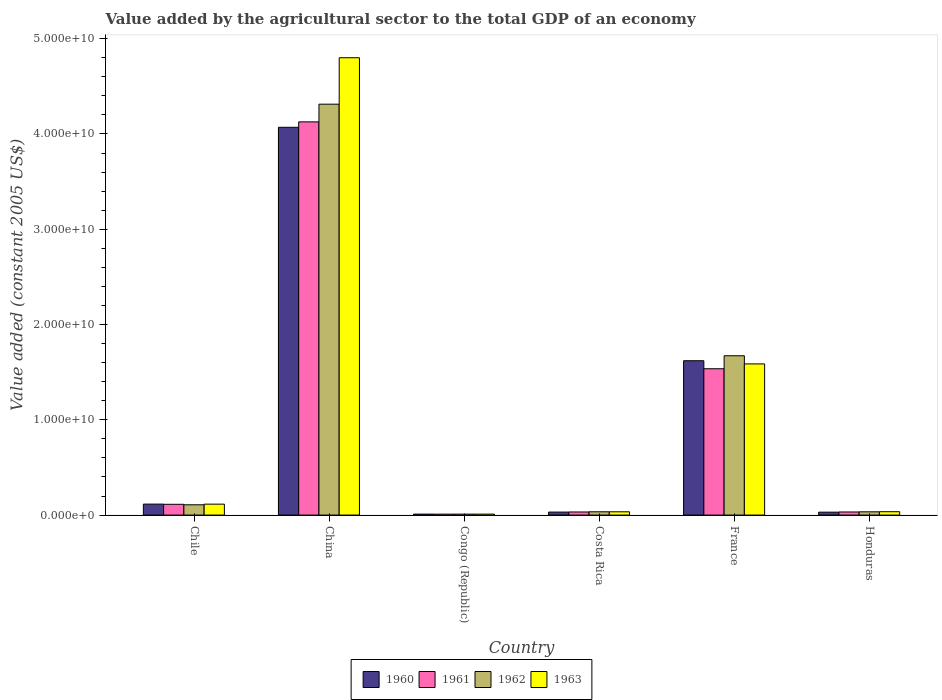How many different coloured bars are there?
Your answer should be compact. 4. How many groups of bars are there?
Offer a very short reply. 6. What is the label of the 4th group of bars from the left?
Offer a terse response. Costa Rica. What is the value added by the agricultural sector in 1961 in Congo (Republic)?
Make the answer very short. 9.74e+07. Across all countries, what is the maximum value added by the agricultural sector in 1961?
Ensure brevity in your answer.  4.13e+1. Across all countries, what is the minimum value added by the agricultural sector in 1962?
Provide a short and direct response. 9.79e+07. In which country was the value added by the agricultural sector in 1963 maximum?
Ensure brevity in your answer.  China. In which country was the value added by the agricultural sector in 1961 minimum?
Offer a terse response. Congo (Republic). What is the total value added by the agricultural sector in 1961 in the graph?
Provide a succinct answer. 5.85e+1. What is the difference between the value added by the agricultural sector in 1963 in Chile and that in Honduras?
Keep it short and to the point. 7.93e+08. What is the difference between the value added by the agricultural sector in 1961 in Honduras and the value added by the agricultural sector in 1962 in China?
Offer a very short reply. -4.28e+1. What is the average value added by the agricultural sector in 1960 per country?
Your answer should be very brief. 9.79e+09. What is the difference between the value added by the agricultural sector of/in 1963 and value added by the agricultural sector of/in 1960 in China?
Your answer should be compact. 7.30e+09. What is the ratio of the value added by the agricultural sector in 1963 in Congo (Republic) to that in France?
Make the answer very short. 0.01. What is the difference between the highest and the second highest value added by the agricultural sector in 1963?
Make the answer very short. -4.69e+1. What is the difference between the highest and the lowest value added by the agricultural sector in 1962?
Offer a terse response. 4.30e+1. What does the 2nd bar from the left in Congo (Republic) represents?
Your answer should be compact. 1961. Is it the case that in every country, the sum of the value added by the agricultural sector in 1961 and value added by the agricultural sector in 1960 is greater than the value added by the agricultural sector in 1962?
Your answer should be compact. Yes. How many bars are there?
Your answer should be very brief. 24. Are all the bars in the graph horizontal?
Give a very brief answer. No. What is the difference between two consecutive major ticks on the Y-axis?
Offer a very short reply. 1.00e+1. Are the values on the major ticks of Y-axis written in scientific E-notation?
Your response must be concise. Yes. Does the graph contain any zero values?
Keep it short and to the point. No. Does the graph contain grids?
Your answer should be very brief. No. What is the title of the graph?
Offer a very short reply. Value added by the agricultural sector to the total GDP of an economy. Does "1985" appear as one of the legend labels in the graph?
Provide a succinct answer. No. What is the label or title of the X-axis?
Offer a terse response. Country. What is the label or title of the Y-axis?
Your answer should be compact. Value added (constant 2005 US$). What is the Value added (constant 2005 US$) of 1960 in Chile?
Ensure brevity in your answer.  1.15e+09. What is the Value added (constant 2005 US$) of 1961 in Chile?
Your response must be concise. 1.13e+09. What is the Value added (constant 2005 US$) of 1962 in Chile?
Your answer should be compact. 1.08e+09. What is the Value added (constant 2005 US$) in 1963 in Chile?
Give a very brief answer. 1.15e+09. What is the Value added (constant 2005 US$) of 1960 in China?
Offer a very short reply. 4.07e+1. What is the Value added (constant 2005 US$) of 1961 in China?
Make the answer very short. 4.13e+1. What is the Value added (constant 2005 US$) in 1962 in China?
Your answer should be compact. 4.31e+1. What is the Value added (constant 2005 US$) in 1963 in China?
Keep it short and to the point. 4.80e+1. What is the Value added (constant 2005 US$) in 1960 in Congo (Republic)?
Ensure brevity in your answer.  1.01e+08. What is the Value added (constant 2005 US$) of 1961 in Congo (Republic)?
Provide a succinct answer. 9.74e+07. What is the Value added (constant 2005 US$) of 1962 in Congo (Republic)?
Provide a short and direct response. 9.79e+07. What is the Value added (constant 2005 US$) of 1963 in Congo (Republic)?
Keep it short and to the point. 9.86e+07. What is the Value added (constant 2005 US$) of 1960 in Costa Rica?
Your response must be concise. 3.13e+08. What is the Value added (constant 2005 US$) in 1961 in Costa Rica?
Your response must be concise. 3.24e+08. What is the Value added (constant 2005 US$) of 1962 in Costa Rica?
Offer a very short reply. 3.44e+08. What is the Value added (constant 2005 US$) of 1963 in Costa Rica?
Your answer should be compact. 3.43e+08. What is the Value added (constant 2005 US$) of 1960 in France?
Your answer should be very brief. 1.62e+1. What is the Value added (constant 2005 US$) in 1961 in France?
Your answer should be very brief. 1.54e+1. What is the Value added (constant 2005 US$) of 1962 in France?
Offer a terse response. 1.67e+1. What is the Value added (constant 2005 US$) of 1963 in France?
Your answer should be very brief. 1.59e+1. What is the Value added (constant 2005 US$) in 1960 in Honduras?
Provide a short and direct response. 3.05e+08. What is the Value added (constant 2005 US$) of 1961 in Honduras?
Make the answer very short. 3.25e+08. What is the Value added (constant 2005 US$) of 1962 in Honduras?
Offer a terse response. 3.41e+08. What is the Value added (constant 2005 US$) in 1963 in Honduras?
Provide a short and direct response. 3.53e+08. Across all countries, what is the maximum Value added (constant 2005 US$) in 1960?
Offer a very short reply. 4.07e+1. Across all countries, what is the maximum Value added (constant 2005 US$) of 1961?
Provide a short and direct response. 4.13e+1. Across all countries, what is the maximum Value added (constant 2005 US$) of 1962?
Your answer should be very brief. 4.31e+1. Across all countries, what is the maximum Value added (constant 2005 US$) of 1963?
Your answer should be compact. 4.80e+1. Across all countries, what is the minimum Value added (constant 2005 US$) in 1960?
Your response must be concise. 1.01e+08. Across all countries, what is the minimum Value added (constant 2005 US$) of 1961?
Your response must be concise. 9.74e+07. Across all countries, what is the minimum Value added (constant 2005 US$) of 1962?
Offer a terse response. 9.79e+07. Across all countries, what is the minimum Value added (constant 2005 US$) in 1963?
Offer a terse response. 9.86e+07. What is the total Value added (constant 2005 US$) of 1960 in the graph?
Your response must be concise. 5.88e+1. What is the total Value added (constant 2005 US$) of 1961 in the graph?
Keep it short and to the point. 5.85e+1. What is the total Value added (constant 2005 US$) in 1962 in the graph?
Keep it short and to the point. 6.17e+1. What is the total Value added (constant 2005 US$) in 1963 in the graph?
Your response must be concise. 6.58e+1. What is the difference between the Value added (constant 2005 US$) of 1960 in Chile and that in China?
Make the answer very short. -3.95e+1. What is the difference between the Value added (constant 2005 US$) of 1961 in Chile and that in China?
Provide a short and direct response. -4.01e+1. What is the difference between the Value added (constant 2005 US$) of 1962 in Chile and that in China?
Offer a very short reply. -4.20e+1. What is the difference between the Value added (constant 2005 US$) in 1963 in Chile and that in China?
Make the answer very short. -4.69e+1. What is the difference between the Value added (constant 2005 US$) of 1960 in Chile and that in Congo (Republic)?
Offer a very short reply. 1.05e+09. What is the difference between the Value added (constant 2005 US$) of 1961 in Chile and that in Congo (Republic)?
Give a very brief answer. 1.03e+09. What is the difference between the Value added (constant 2005 US$) in 1962 in Chile and that in Congo (Republic)?
Keep it short and to the point. 9.81e+08. What is the difference between the Value added (constant 2005 US$) in 1963 in Chile and that in Congo (Republic)?
Give a very brief answer. 1.05e+09. What is the difference between the Value added (constant 2005 US$) in 1960 in Chile and that in Costa Rica?
Offer a terse response. 8.39e+08. What is the difference between the Value added (constant 2005 US$) in 1961 in Chile and that in Costa Rica?
Give a very brief answer. 8.06e+08. What is the difference between the Value added (constant 2005 US$) of 1962 in Chile and that in Costa Rica?
Offer a very short reply. 7.35e+08. What is the difference between the Value added (constant 2005 US$) of 1963 in Chile and that in Costa Rica?
Give a very brief answer. 8.03e+08. What is the difference between the Value added (constant 2005 US$) in 1960 in Chile and that in France?
Make the answer very short. -1.50e+1. What is the difference between the Value added (constant 2005 US$) of 1961 in Chile and that in France?
Give a very brief answer. -1.42e+1. What is the difference between the Value added (constant 2005 US$) in 1962 in Chile and that in France?
Give a very brief answer. -1.56e+1. What is the difference between the Value added (constant 2005 US$) in 1963 in Chile and that in France?
Keep it short and to the point. -1.47e+1. What is the difference between the Value added (constant 2005 US$) of 1960 in Chile and that in Honduras?
Your answer should be very brief. 8.46e+08. What is the difference between the Value added (constant 2005 US$) of 1961 in Chile and that in Honduras?
Keep it short and to the point. 8.05e+08. What is the difference between the Value added (constant 2005 US$) of 1962 in Chile and that in Honduras?
Offer a very short reply. 7.38e+08. What is the difference between the Value added (constant 2005 US$) in 1963 in Chile and that in Honduras?
Offer a terse response. 7.93e+08. What is the difference between the Value added (constant 2005 US$) in 1960 in China and that in Congo (Republic)?
Ensure brevity in your answer.  4.06e+1. What is the difference between the Value added (constant 2005 US$) in 1961 in China and that in Congo (Republic)?
Your answer should be compact. 4.12e+1. What is the difference between the Value added (constant 2005 US$) of 1962 in China and that in Congo (Republic)?
Your answer should be compact. 4.30e+1. What is the difference between the Value added (constant 2005 US$) in 1963 in China and that in Congo (Republic)?
Provide a succinct answer. 4.79e+1. What is the difference between the Value added (constant 2005 US$) in 1960 in China and that in Costa Rica?
Your answer should be compact. 4.04e+1. What is the difference between the Value added (constant 2005 US$) of 1961 in China and that in Costa Rica?
Offer a very short reply. 4.09e+1. What is the difference between the Value added (constant 2005 US$) of 1962 in China and that in Costa Rica?
Provide a succinct answer. 4.28e+1. What is the difference between the Value added (constant 2005 US$) in 1963 in China and that in Costa Rica?
Your answer should be compact. 4.77e+1. What is the difference between the Value added (constant 2005 US$) of 1960 in China and that in France?
Your answer should be very brief. 2.45e+1. What is the difference between the Value added (constant 2005 US$) of 1961 in China and that in France?
Offer a very short reply. 2.59e+1. What is the difference between the Value added (constant 2005 US$) of 1962 in China and that in France?
Make the answer very short. 2.64e+1. What is the difference between the Value added (constant 2005 US$) of 1963 in China and that in France?
Offer a very short reply. 3.21e+1. What is the difference between the Value added (constant 2005 US$) of 1960 in China and that in Honduras?
Give a very brief answer. 4.04e+1. What is the difference between the Value added (constant 2005 US$) in 1961 in China and that in Honduras?
Your answer should be very brief. 4.09e+1. What is the difference between the Value added (constant 2005 US$) of 1962 in China and that in Honduras?
Provide a short and direct response. 4.28e+1. What is the difference between the Value added (constant 2005 US$) in 1963 in China and that in Honduras?
Provide a succinct answer. 4.76e+1. What is the difference between the Value added (constant 2005 US$) in 1960 in Congo (Republic) and that in Costa Rica?
Make the answer very short. -2.12e+08. What is the difference between the Value added (constant 2005 US$) in 1961 in Congo (Republic) and that in Costa Rica?
Your response must be concise. -2.27e+08. What is the difference between the Value added (constant 2005 US$) in 1962 in Congo (Republic) and that in Costa Rica?
Your answer should be compact. -2.46e+08. What is the difference between the Value added (constant 2005 US$) of 1963 in Congo (Republic) and that in Costa Rica?
Your answer should be very brief. -2.45e+08. What is the difference between the Value added (constant 2005 US$) in 1960 in Congo (Republic) and that in France?
Your answer should be compact. -1.61e+1. What is the difference between the Value added (constant 2005 US$) in 1961 in Congo (Republic) and that in France?
Give a very brief answer. -1.53e+1. What is the difference between the Value added (constant 2005 US$) of 1962 in Congo (Republic) and that in France?
Offer a very short reply. -1.66e+1. What is the difference between the Value added (constant 2005 US$) in 1963 in Congo (Republic) and that in France?
Keep it short and to the point. -1.58e+1. What is the difference between the Value added (constant 2005 US$) of 1960 in Congo (Republic) and that in Honduras?
Make the answer very short. -2.04e+08. What is the difference between the Value added (constant 2005 US$) in 1961 in Congo (Republic) and that in Honduras?
Provide a succinct answer. -2.28e+08. What is the difference between the Value added (constant 2005 US$) in 1962 in Congo (Republic) and that in Honduras?
Ensure brevity in your answer.  -2.43e+08. What is the difference between the Value added (constant 2005 US$) of 1963 in Congo (Republic) and that in Honduras?
Keep it short and to the point. -2.55e+08. What is the difference between the Value added (constant 2005 US$) in 1960 in Costa Rica and that in France?
Offer a terse response. -1.59e+1. What is the difference between the Value added (constant 2005 US$) of 1961 in Costa Rica and that in France?
Your response must be concise. -1.50e+1. What is the difference between the Value added (constant 2005 US$) of 1962 in Costa Rica and that in France?
Make the answer very short. -1.64e+1. What is the difference between the Value added (constant 2005 US$) in 1963 in Costa Rica and that in France?
Provide a succinct answer. -1.55e+1. What is the difference between the Value added (constant 2005 US$) of 1960 in Costa Rica and that in Honduras?
Give a very brief answer. 7.61e+06. What is the difference between the Value added (constant 2005 US$) of 1961 in Costa Rica and that in Honduras?
Your answer should be compact. -8.14e+05. What is the difference between the Value added (constant 2005 US$) of 1962 in Costa Rica and that in Honduras?
Offer a very short reply. 3.61e+06. What is the difference between the Value added (constant 2005 US$) in 1963 in Costa Rica and that in Honduras?
Provide a short and direct response. -9.78e+06. What is the difference between the Value added (constant 2005 US$) of 1960 in France and that in Honduras?
Make the answer very short. 1.59e+1. What is the difference between the Value added (constant 2005 US$) of 1961 in France and that in Honduras?
Give a very brief answer. 1.50e+1. What is the difference between the Value added (constant 2005 US$) of 1962 in France and that in Honduras?
Provide a short and direct response. 1.64e+1. What is the difference between the Value added (constant 2005 US$) in 1963 in France and that in Honduras?
Your answer should be compact. 1.55e+1. What is the difference between the Value added (constant 2005 US$) of 1960 in Chile and the Value added (constant 2005 US$) of 1961 in China?
Ensure brevity in your answer.  -4.01e+1. What is the difference between the Value added (constant 2005 US$) in 1960 in Chile and the Value added (constant 2005 US$) in 1962 in China?
Offer a terse response. -4.20e+1. What is the difference between the Value added (constant 2005 US$) of 1960 in Chile and the Value added (constant 2005 US$) of 1963 in China?
Offer a very short reply. -4.68e+1. What is the difference between the Value added (constant 2005 US$) in 1961 in Chile and the Value added (constant 2005 US$) in 1962 in China?
Keep it short and to the point. -4.20e+1. What is the difference between the Value added (constant 2005 US$) of 1961 in Chile and the Value added (constant 2005 US$) of 1963 in China?
Your answer should be very brief. -4.69e+1. What is the difference between the Value added (constant 2005 US$) in 1962 in Chile and the Value added (constant 2005 US$) in 1963 in China?
Ensure brevity in your answer.  -4.69e+1. What is the difference between the Value added (constant 2005 US$) of 1960 in Chile and the Value added (constant 2005 US$) of 1961 in Congo (Republic)?
Offer a very short reply. 1.05e+09. What is the difference between the Value added (constant 2005 US$) of 1960 in Chile and the Value added (constant 2005 US$) of 1962 in Congo (Republic)?
Your response must be concise. 1.05e+09. What is the difference between the Value added (constant 2005 US$) in 1960 in Chile and the Value added (constant 2005 US$) in 1963 in Congo (Republic)?
Your answer should be compact. 1.05e+09. What is the difference between the Value added (constant 2005 US$) of 1961 in Chile and the Value added (constant 2005 US$) of 1962 in Congo (Republic)?
Provide a succinct answer. 1.03e+09. What is the difference between the Value added (constant 2005 US$) of 1961 in Chile and the Value added (constant 2005 US$) of 1963 in Congo (Republic)?
Your answer should be compact. 1.03e+09. What is the difference between the Value added (constant 2005 US$) of 1962 in Chile and the Value added (constant 2005 US$) of 1963 in Congo (Republic)?
Offer a very short reply. 9.81e+08. What is the difference between the Value added (constant 2005 US$) in 1960 in Chile and the Value added (constant 2005 US$) in 1961 in Costa Rica?
Make the answer very short. 8.27e+08. What is the difference between the Value added (constant 2005 US$) of 1960 in Chile and the Value added (constant 2005 US$) of 1962 in Costa Rica?
Give a very brief answer. 8.07e+08. What is the difference between the Value added (constant 2005 US$) in 1960 in Chile and the Value added (constant 2005 US$) in 1963 in Costa Rica?
Your response must be concise. 8.08e+08. What is the difference between the Value added (constant 2005 US$) in 1961 in Chile and the Value added (constant 2005 US$) in 1962 in Costa Rica?
Keep it short and to the point. 7.86e+08. What is the difference between the Value added (constant 2005 US$) in 1961 in Chile and the Value added (constant 2005 US$) in 1963 in Costa Rica?
Keep it short and to the point. 7.87e+08. What is the difference between the Value added (constant 2005 US$) of 1962 in Chile and the Value added (constant 2005 US$) of 1963 in Costa Rica?
Ensure brevity in your answer.  7.36e+08. What is the difference between the Value added (constant 2005 US$) in 1960 in Chile and the Value added (constant 2005 US$) in 1961 in France?
Offer a very short reply. -1.42e+1. What is the difference between the Value added (constant 2005 US$) of 1960 in Chile and the Value added (constant 2005 US$) of 1962 in France?
Offer a very short reply. -1.56e+1. What is the difference between the Value added (constant 2005 US$) in 1960 in Chile and the Value added (constant 2005 US$) in 1963 in France?
Make the answer very short. -1.47e+1. What is the difference between the Value added (constant 2005 US$) of 1961 in Chile and the Value added (constant 2005 US$) of 1962 in France?
Make the answer very short. -1.56e+1. What is the difference between the Value added (constant 2005 US$) in 1961 in Chile and the Value added (constant 2005 US$) in 1963 in France?
Ensure brevity in your answer.  -1.47e+1. What is the difference between the Value added (constant 2005 US$) of 1962 in Chile and the Value added (constant 2005 US$) of 1963 in France?
Make the answer very short. -1.48e+1. What is the difference between the Value added (constant 2005 US$) in 1960 in Chile and the Value added (constant 2005 US$) in 1961 in Honduras?
Offer a very short reply. 8.27e+08. What is the difference between the Value added (constant 2005 US$) in 1960 in Chile and the Value added (constant 2005 US$) in 1962 in Honduras?
Provide a succinct answer. 8.11e+08. What is the difference between the Value added (constant 2005 US$) in 1960 in Chile and the Value added (constant 2005 US$) in 1963 in Honduras?
Ensure brevity in your answer.  7.99e+08. What is the difference between the Value added (constant 2005 US$) in 1961 in Chile and the Value added (constant 2005 US$) in 1962 in Honduras?
Make the answer very short. 7.90e+08. What is the difference between the Value added (constant 2005 US$) in 1961 in Chile and the Value added (constant 2005 US$) in 1963 in Honduras?
Give a very brief answer. 7.78e+08. What is the difference between the Value added (constant 2005 US$) in 1962 in Chile and the Value added (constant 2005 US$) in 1963 in Honduras?
Ensure brevity in your answer.  7.26e+08. What is the difference between the Value added (constant 2005 US$) in 1960 in China and the Value added (constant 2005 US$) in 1961 in Congo (Republic)?
Your answer should be compact. 4.06e+1. What is the difference between the Value added (constant 2005 US$) in 1960 in China and the Value added (constant 2005 US$) in 1962 in Congo (Republic)?
Offer a very short reply. 4.06e+1. What is the difference between the Value added (constant 2005 US$) in 1960 in China and the Value added (constant 2005 US$) in 1963 in Congo (Republic)?
Make the answer very short. 4.06e+1. What is the difference between the Value added (constant 2005 US$) in 1961 in China and the Value added (constant 2005 US$) in 1962 in Congo (Republic)?
Give a very brief answer. 4.12e+1. What is the difference between the Value added (constant 2005 US$) of 1961 in China and the Value added (constant 2005 US$) of 1963 in Congo (Republic)?
Make the answer very short. 4.12e+1. What is the difference between the Value added (constant 2005 US$) in 1962 in China and the Value added (constant 2005 US$) in 1963 in Congo (Republic)?
Ensure brevity in your answer.  4.30e+1. What is the difference between the Value added (constant 2005 US$) of 1960 in China and the Value added (constant 2005 US$) of 1961 in Costa Rica?
Your answer should be very brief. 4.04e+1. What is the difference between the Value added (constant 2005 US$) of 1960 in China and the Value added (constant 2005 US$) of 1962 in Costa Rica?
Give a very brief answer. 4.04e+1. What is the difference between the Value added (constant 2005 US$) of 1960 in China and the Value added (constant 2005 US$) of 1963 in Costa Rica?
Offer a terse response. 4.04e+1. What is the difference between the Value added (constant 2005 US$) in 1961 in China and the Value added (constant 2005 US$) in 1962 in Costa Rica?
Offer a terse response. 4.09e+1. What is the difference between the Value added (constant 2005 US$) of 1961 in China and the Value added (constant 2005 US$) of 1963 in Costa Rica?
Provide a succinct answer. 4.09e+1. What is the difference between the Value added (constant 2005 US$) of 1962 in China and the Value added (constant 2005 US$) of 1963 in Costa Rica?
Give a very brief answer. 4.28e+1. What is the difference between the Value added (constant 2005 US$) in 1960 in China and the Value added (constant 2005 US$) in 1961 in France?
Give a very brief answer. 2.53e+1. What is the difference between the Value added (constant 2005 US$) of 1960 in China and the Value added (constant 2005 US$) of 1962 in France?
Ensure brevity in your answer.  2.40e+1. What is the difference between the Value added (constant 2005 US$) of 1960 in China and the Value added (constant 2005 US$) of 1963 in France?
Offer a terse response. 2.48e+1. What is the difference between the Value added (constant 2005 US$) of 1961 in China and the Value added (constant 2005 US$) of 1962 in France?
Offer a very short reply. 2.45e+1. What is the difference between the Value added (constant 2005 US$) of 1961 in China and the Value added (constant 2005 US$) of 1963 in France?
Make the answer very short. 2.54e+1. What is the difference between the Value added (constant 2005 US$) of 1962 in China and the Value added (constant 2005 US$) of 1963 in France?
Offer a terse response. 2.73e+1. What is the difference between the Value added (constant 2005 US$) of 1960 in China and the Value added (constant 2005 US$) of 1961 in Honduras?
Your answer should be compact. 4.04e+1. What is the difference between the Value added (constant 2005 US$) of 1960 in China and the Value added (constant 2005 US$) of 1962 in Honduras?
Your answer should be compact. 4.04e+1. What is the difference between the Value added (constant 2005 US$) of 1960 in China and the Value added (constant 2005 US$) of 1963 in Honduras?
Ensure brevity in your answer.  4.03e+1. What is the difference between the Value added (constant 2005 US$) in 1961 in China and the Value added (constant 2005 US$) in 1962 in Honduras?
Make the answer very short. 4.09e+1. What is the difference between the Value added (constant 2005 US$) in 1961 in China and the Value added (constant 2005 US$) in 1963 in Honduras?
Your answer should be compact. 4.09e+1. What is the difference between the Value added (constant 2005 US$) of 1962 in China and the Value added (constant 2005 US$) of 1963 in Honduras?
Keep it short and to the point. 4.28e+1. What is the difference between the Value added (constant 2005 US$) in 1960 in Congo (Republic) and the Value added (constant 2005 US$) in 1961 in Costa Rica?
Ensure brevity in your answer.  -2.24e+08. What is the difference between the Value added (constant 2005 US$) of 1960 in Congo (Republic) and the Value added (constant 2005 US$) of 1962 in Costa Rica?
Keep it short and to the point. -2.43e+08. What is the difference between the Value added (constant 2005 US$) of 1960 in Congo (Republic) and the Value added (constant 2005 US$) of 1963 in Costa Rica?
Offer a very short reply. -2.42e+08. What is the difference between the Value added (constant 2005 US$) of 1961 in Congo (Republic) and the Value added (constant 2005 US$) of 1962 in Costa Rica?
Provide a short and direct response. -2.47e+08. What is the difference between the Value added (constant 2005 US$) in 1961 in Congo (Republic) and the Value added (constant 2005 US$) in 1963 in Costa Rica?
Make the answer very short. -2.46e+08. What is the difference between the Value added (constant 2005 US$) in 1962 in Congo (Republic) and the Value added (constant 2005 US$) in 1963 in Costa Rica?
Your response must be concise. -2.45e+08. What is the difference between the Value added (constant 2005 US$) of 1960 in Congo (Republic) and the Value added (constant 2005 US$) of 1961 in France?
Offer a very short reply. -1.53e+1. What is the difference between the Value added (constant 2005 US$) of 1960 in Congo (Republic) and the Value added (constant 2005 US$) of 1962 in France?
Make the answer very short. -1.66e+1. What is the difference between the Value added (constant 2005 US$) of 1960 in Congo (Republic) and the Value added (constant 2005 US$) of 1963 in France?
Offer a terse response. -1.58e+1. What is the difference between the Value added (constant 2005 US$) in 1961 in Congo (Republic) and the Value added (constant 2005 US$) in 1962 in France?
Provide a succinct answer. -1.66e+1. What is the difference between the Value added (constant 2005 US$) in 1961 in Congo (Republic) and the Value added (constant 2005 US$) in 1963 in France?
Provide a short and direct response. -1.58e+1. What is the difference between the Value added (constant 2005 US$) of 1962 in Congo (Republic) and the Value added (constant 2005 US$) of 1963 in France?
Offer a very short reply. -1.58e+1. What is the difference between the Value added (constant 2005 US$) in 1960 in Congo (Republic) and the Value added (constant 2005 US$) in 1961 in Honduras?
Make the answer very short. -2.24e+08. What is the difference between the Value added (constant 2005 US$) in 1960 in Congo (Republic) and the Value added (constant 2005 US$) in 1962 in Honduras?
Offer a very short reply. -2.40e+08. What is the difference between the Value added (constant 2005 US$) in 1960 in Congo (Republic) and the Value added (constant 2005 US$) in 1963 in Honduras?
Give a very brief answer. -2.52e+08. What is the difference between the Value added (constant 2005 US$) in 1961 in Congo (Republic) and the Value added (constant 2005 US$) in 1962 in Honduras?
Give a very brief answer. -2.43e+08. What is the difference between the Value added (constant 2005 US$) in 1961 in Congo (Republic) and the Value added (constant 2005 US$) in 1963 in Honduras?
Your answer should be compact. -2.56e+08. What is the difference between the Value added (constant 2005 US$) of 1962 in Congo (Republic) and the Value added (constant 2005 US$) of 1963 in Honduras?
Provide a succinct answer. -2.55e+08. What is the difference between the Value added (constant 2005 US$) of 1960 in Costa Rica and the Value added (constant 2005 US$) of 1961 in France?
Make the answer very short. -1.50e+1. What is the difference between the Value added (constant 2005 US$) in 1960 in Costa Rica and the Value added (constant 2005 US$) in 1962 in France?
Offer a very short reply. -1.64e+1. What is the difference between the Value added (constant 2005 US$) of 1960 in Costa Rica and the Value added (constant 2005 US$) of 1963 in France?
Provide a succinct answer. -1.56e+1. What is the difference between the Value added (constant 2005 US$) of 1961 in Costa Rica and the Value added (constant 2005 US$) of 1962 in France?
Make the answer very short. -1.64e+1. What is the difference between the Value added (constant 2005 US$) of 1961 in Costa Rica and the Value added (constant 2005 US$) of 1963 in France?
Your answer should be compact. -1.55e+1. What is the difference between the Value added (constant 2005 US$) of 1962 in Costa Rica and the Value added (constant 2005 US$) of 1963 in France?
Your response must be concise. -1.55e+1. What is the difference between the Value added (constant 2005 US$) of 1960 in Costa Rica and the Value added (constant 2005 US$) of 1961 in Honduras?
Provide a short and direct response. -1.23e+07. What is the difference between the Value added (constant 2005 US$) in 1960 in Costa Rica and the Value added (constant 2005 US$) in 1962 in Honduras?
Give a very brief answer. -2.78e+07. What is the difference between the Value added (constant 2005 US$) of 1960 in Costa Rica and the Value added (constant 2005 US$) of 1963 in Honduras?
Offer a very short reply. -4.02e+07. What is the difference between the Value added (constant 2005 US$) of 1961 in Costa Rica and the Value added (constant 2005 US$) of 1962 in Honduras?
Give a very brief answer. -1.63e+07. What is the difference between the Value added (constant 2005 US$) in 1961 in Costa Rica and the Value added (constant 2005 US$) in 1963 in Honduras?
Make the answer very short. -2.87e+07. What is the difference between the Value added (constant 2005 US$) of 1962 in Costa Rica and the Value added (constant 2005 US$) of 1963 in Honduras?
Offer a terse response. -8.78e+06. What is the difference between the Value added (constant 2005 US$) of 1960 in France and the Value added (constant 2005 US$) of 1961 in Honduras?
Offer a terse response. 1.59e+1. What is the difference between the Value added (constant 2005 US$) in 1960 in France and the Value added (constant 2005 US$) in 1962 in Honduras?
Offer a very short reply. 1.59e+1. What is the difference between the Value added (constant 2005 US$) of 1960 in France and the Value added (constant 2005 US$) of 1963 in Honduras?
Provide a short and direct response. 1.58e+1. What is the difference between the Value added (constant 2005 US$) in 1961 in France and the Value added (constant 2005 US$) in 1962 in Honduras?
Keep it short and to the point. 1.50e+1. What is the difference between the Value added (constant 2005 US$) of 1961 in France and the Value added (constant 2005 US$) of 1963 in Honduras?
Your answer should be compact. 1.50e+1. What is the difference between the Value added (constant 2005 US$) of 1962 in France and the Value added (constant 2005 US$) of 1963 in Honduras?
Provide a short and direct response. 1.64e+1. What is the average Value added (constant 2005 US$) in 1960 per country?
Provide a succinct answer. 9.79e+09. What is the average Value added (constant 2005 US$) of 1961 per country?
Provide a succinct answer. 9.75e+09. What is the average Value added (constant 2005 US$) of 1962 per country?
Your answer should be very brief. 1.03e+1. What is the average Value added (constant 2005 US$) of 1963 per country?
Offer a terse response. 1.10e+1. What is the difference between the Value added (constant 2005 US$) in 1960 and Value added (constant 2005 US$) in 1961 in Chile?
Provide a short and direct response. 2.12e+07. What is the difference between the Value added (constant 2005 US$) of 1960 and Value added (constant 2005 US$) of 1962 in Chile?
Your response must be concise. 7.27e+07. What is the difference between the Value added (constant 2005 US$) of 1960 and Value added (constant 2005 US$) of 1963 in Chile?
Ensure brevity in your answer.  5.74e+06. What is the difference between the Value added (constant 2005 US$) of 1961 and Value added (constant 2005 US$) of 1962 in Chile?
Keep it short and to the point. 5.15e+07. What is the difference between the Value added (constant 2005 US$) in 1961 and Value added (constant 2005 US$) in 1963 in Chile?
Provide a short and direct response. -1.54e+07. What is the difference between the Value added (constant 2005 US$) in 1962 and Value added (constant 2005 US$) in 1963 in Chile?
Provide a short and direct response. -6.69e+07. What is the difference between the Value added (constant 2005 US$) of 1960 and Value added (constant 2005 US$) of 1961 in China?
Give a very brief answer. -5.70e+08. What is the difference between the Value added (constant 2005 US$) in 1960 and Value added (constant 2005 US$) in 1962 in China?
Ensure brevity in your answer.  -2.43e+09. What is the difference between the Value added (constant 2005 US$) in 1960 and Value added (constant 2005 US$) in 1963 in China?
Ensure brevity in your answer.  -7.30e+09. What is the difference between the Value added (constant 2005 US$) in 1961 and Value added (constant 2005 US$) in 1962 in China?
Provide a short and direct response. -1.86e+09. What is the difference between the Value added (constant 2005 US$) of 1961 and Value added (constant 2005 US$) of 1963 in China?
Offer a terse response. -6.73e+09. What is the difference between the Value added (constant 2005 US$) in 1962 and Value added (constant 2005 US$) in 1963 in China?
Offer a very short reply. -4.87e+09. What is the difference between the Value added (constant 2005 US$) of 1960 and Value added (constant 2005 US$) of 1961 in Congo (Republic)?
Offer a terse response. 3.61e+06. What is the difference between the Value added (constant 2005 US$) in 1960 and Value added (constant 2005 US$) in 1962 in Congo (Republic)?
Make the answer very short. 3.02e+06. What is the difference between the Value added (constant 2005 US$) of 1960 and Value added (constant 2005 US$) of 1963 in Congo (Republic)?
Ensure brevity in your answer.  2.34e+06. What is the difference between the Value added (constant 2005 US$) in 1961 and Value added (constant 2005 US$) in 1962 in Congo (Republic)?
Your answer should be very brief. -5.86e+05. What is the difference between the Value added (constant 2005 US$) in 1961 and Value added (constant 2005 US$) in 1963 in Congo (Republic)?
Offer a terse response. -1.27e+06. What is the difference between the Value added (constant 2005 US$) in 1962 and Value added (constant 2005 US$) in 1963 in Congo (Republic)?
Provide a succinct answer. -6.85e+05. What is the difference between the Value added (constant 2005 US$) in 1960 and Value added (constant 2005 US$) in 1961 in Costa Rica?
Give a very brief answer. -1.15e+07. What is the difference between the Value added (constant 2005 US$) of 1960 and Value added (constant 2005 US$) of 1962 in Costa Rica?
Keep it short and to the point. -3.14e+07. What is the difference between the Value added (constant 2005 US$) of 1960 and Value added (constant 2005 US$) of 1963 in Costa Rica?
Ensure brevity in your answer.  -3.04e+07. What is the difference between the Value added (constant 2005 US$) of 1961 and Value added (constant 2005 US$) of 1962 in Costa Rica?
Your answer should be compact. -1.99e+07. What is the difference between the Value added (constant 2005 US$) in 1961 and Value added (constant 2005 US$) in 1963 in Costa Rica?
Provide a short and direct response. -1.89e+07. What is the difference between the Value added (constant 2005 US$) in 1962 and Value added (constant 2005 US$) in 1963 in Costa Rica?
Your answer should be very brief. 1.00e+06. What is the difference between the Value added (constant 2005 US$) in 1960 and Value added (constant 2005 US$) in 1961 in France?
Provide a short and direct response. 8.42e+08. What is the difference between the Value added (constant 2005 US$) of 1960 and Value added (constant 2005 US$) of 1962 in France?
Your answer should be very brief. -5.20e+08. What is the difference between the Value added (constant 2005 US$) in 1960 and Value added (constant 2005 US$) in 1963 in France?
Offer a very short reply. 3.35e+08. What is the difference between the Value added (constant 2005 US$) in 1961 and Value added (constant 2005 US$) in 1962 in France?
Keep it short and to the point. -1.36e+09. What is the difference between the Value added (constant 2005 US$) of 1961 and Value added (constant 2005 US$) of 1963 in France?
Your response must be concise. -5.07e+08. What is the difference between the Value added (constant 2005 US$) of 1962 and Value added (constant 2005 US$) of 1963 in France?
Give a very brief answer. 8.56e+08. What is the difference between the Value added (constant 2005 US$) of 1960 and Value added (constant 2005 US$) of 1961 in Honduras?
Give a very brief answer. -1.99e+07. What is the difference between the Value added (constant 2005 US$) in 1960 and Value added (constant 2005 US$) in 1962 in Honduras?
Provide a short and direct response. -3.54e+07. What is the difference between the Value added (constant 2005 US$) of 1960 and Value added (constant 2005 US$) of 1963 in Honduras?
Offer a very short reply. -4.78e+07. What is the difference between the Value added (constant 2005 US$) of 1961 and Value added (constant 2005 US$) of 1962 in Honduras?
Make the answer very short. -1.55e+07. What is the difference between the Value added (constant 2005 US$) in 1961 and Value added (constant 2005 US$) in 1963 in Honduras?
Offer a very short reply. -2.79e+07. What is the difference between the Value added (constant 2005 US$) of 1962 and Value added (constant 2005 US$) of 1963 in Honduras?
Ensure brevity in your answer.  -1.24e+07. What is the ratio of the Value added (constant 2005 US$) of 1960 in Chile to that in China?
Provide a succinct answer. 0.03. What is the ratio of the Value added (constant 2005 US$) of 1961 in Chile to that in China?
Offer a very short reply. 0.03. What is the ratio of the Value added (constant 2005 US$) of 1962 in Chile to that in China?
Keep it short and to the point. 0.03. What is the ratio of the Value added (constant 2005 US$) of 1963 in Chile to that in China?
Offer a very short reply. 0.02. What is the ratio of the Value added (constant 2005 US$) of 1960 in Chile to that in Congo (Republic)?
Offer a terse response. 11.41. What is the ratio of the Value added (constant 2005 US$) of 1961 in Chile to that in Congo (Republic)?
Offer a very short reply. 11.61. What is the ratio of the Value added (constant 2005 US$) of 1962 in Chile to that in Congo (Republic)?
Offer a terse response. 11.02. What is the ratio of the Value added (constant 2005 US$) in 1963 in Chile to that in Congo (Republic)?
Give a very brief answer. 11.62. What is the ratio of the Value added (constant 2005 US$) in 1960 in Chile to that in Costa Rica?
Offer a terse response. 3.68. What is the ratio of the Value added (constant 2005 US$) in 1961 in Chile to that in Costa Rica?
Your answer should be compact. 3.48. What is the ratio of the Value added (constant 2005 US$) in 1962 in Chile to that in Costa Rica?
Offer a very short reply. 3.13. What is the ratio of the Value added (constant 2005 US$) in 1963 in Chile to that in Costa Rica?
Offer a terse response. 3.34. What is the ratio of the Value added (constant 2005 US$) in 1960 in Chile to that in France?
Make the answer very short. 0.07. What is the ratio of the Value added (constant 2005 US$) in 1961 in Chile to that in France?
Provide a short and direct response. 0.07. What is the ratio of the Value added (constant 2005 US$) of 1962 in Chile to that in France?
Your answer should be compact. 0.06. What is the ratio of the Value added (constant 2005 US$) in 1963 in Chile to that in France?
Offer a very short reply. 0.07. What is the ratio of the Value added (constant 2005 US$) in 1960 in Chile to that in Honduras?
Provide a succinct answer. 3.77. What is the ratio of the Value added (constant 2005 US$) in 1961 in Chile to that in Honduras?
Your response must be concise. 3.48. What is the ratio of the Value added (constant 2005 US$) in 1962 in Chile to that in Honduras?
Keep it short and to the point. 3.17. What is the ratio of the Value added (constant 2005 US$) of 1963 in Chile to that in Honduras?
Provide a succinct answer. 3.25. What is the ratio of the Value added (constant 2005 US$) of 1960 in China to that in Congo (Republic)?
Provide a succinct answer. 403.12. What is the ratio of the Value added (constant 2005 US$) of 1961 in China to that in Congo (Republic)?
Offer a terse response. 423.9. What is the ratio of the Value added (constant 2005 US$) in 1962 in China to that in Congo (Republic)?
Provide a short and direct response. 440.32. What is the ratio of the Value added (constant 2005 US$) in 1963 in China to that in Congo (Republic)?
Your answer should be compact. 486.68. What is the ratio of the Value added (constant 2005 US$) of 1960 in China to that in Costa Rica?
Give a very brief answer. 130.03. What is the ratio of the Value added (constant 2005 US$) in 1961 in China to that in Costa Rica?
Provide a succinct answer. 127.18. What is the ratio of the Value added (constant 2005 US$) in 1962 in China to that in Costa Rica?
Provide a short and direct response. 125.23. What is the ratio of the Value added (constant 2005 US$) in 1963 in China to that in Costa Rica?
Your response must be concise. 139.78. What is the ratio of the Value added (constant 2005 US$) in 1960 in China to that in France?
Keep it short and to the point. 2.51. What is the ratio of the Value added (constant 2005 US$) in 1961 in China to that in France?
Your answer should be compact. 2.69. What is the ratio of the Value added (constant 2005 US$) in 1962 in China to that in France?
Make the answer very short. 2.58. What is the ratio of the Value added (constant 2005 US$) of 1963 in China to that in France?
Give a very brief answer. 3.03. What is the ratio of the Value added (constant 2005 US$) of 1960 in China to that in Honduras?
Make the answer very short. 133.27. What is the ratio of the Value added (constant 2005 US$) in 1961 in China to that in Honduras?
Keep it short and to the point. 126.86. What is the ratio of the Value added (constant 2005 US$) in 1962 in China to that in Honduras?
Offer a terse response. 126.55. What is the ratio of the Value added (constant 2005 US$) of 1963 in China to that in Honduras?
Offer a very short reply. 135.91. What is the ratio of the Value added (constant 2005 US$) in 1960 in Congo (Republic) to that in Costa Rica?
Ensure brevity in your answer.  0.32. What is the ratio of the Value added (constant 2005 US$) in 1962 in Congo (Republic) to that in Costa Rica?
Make the answer very short. 0.28. What is the ratio of the Value added (constant 2005 US$) of 1963 in Congo (Republic) to that in Costa Rica?
Offer a terse response. 0.29. What is the ratio of the Value added (constant 2005 US$) in 1960 in Congo (Republic) to that in France?
Provide a short and direct response. 0.01. What is the ratio of the Value added (constant 2005 US$) of 1961 in Congo (Republic) to that in France?
Give a very brief answer. 0.01. What is the ratio of the Value added (constant 2005 US$) of 1962 in Congo (Republic) to that in France?
Your response must be concise. 0.01. What is the ratio of the Value added (constant 2005 US$) in 1963 in Congo (Republic) to that in France?
Provide a succinct answer. 0.01. What is the ratio of the Value added (constant 2005 US$) in 1960 in Congo (Republic) to that in Honduras?
Offer a terse response. 0.33. What is the ratio of the Value added (constant 2005 US$) in 1961 in Congo (Republic) to that in Honduras?
Provide a succinct answer. 0.3. What is the ratio of the Value added (constant 2005 US$) of 1962 in Congo (Republic) to that in Honduras?
Offer a very short reply. 0.29. What is the ratio of the Value added (constant 2005 US$) of 1963 in Congo (Republic) to that in Honduras?
Offer a very short reply. 0.28. What is the ratio of the Value added (constant 2005 US$) of 1960 in Costa Rica to that in France?
Your answer should be compact. 0.02. What is the ratio of the Value added (constant 2005 US$) in 1961 in Costa Rica to that in France?
Offer a very short reply. 0.02. What is the ratio of the Value added (constant 2005 US$) in 1962 in Costa Rica to that in France?
Offer a terse response. 0.02. What is the ratio of the Value added (constant 2005 US$) of 1963 in Costa Rica to that in France?
Your answer should be compact. 0.02. What is the ratio of the Value added (constant 2005 US$) in 1960 in Costa Rica to that in Honduras?
Your answer should be very brief. 1.02. What is the ratio of the Value added (constant 2005 US$) of 1962 in Costa Rica to that in Honduras?
Ensure brevity in your answer.  1.01. What is the ratio of the Value added (constant 2005 US$) of 1963 in Costa Rica to that in Honduras?
Your answer should be compact. 0.97. What is the ratio of the Value added (constant 2005 US$) in 1960 in France to that in Honduras?
Your answer should be compact. 53.05. What is the ratio of the Value added (constant 2005 US$) in 1961 in France to that in Honduras?
Make the answer very short. 47.21. What is the ratio of the Value added (constant 2005 US$) of 1962 in France to that in Honduras?
Provide a short and direct response. 49.07. What is the ratio of the Value added (constant 2005 US$) in 1963 in France to that in Honduras?
Offer a very short reply. 44.92. What is the difference between the highest and the second highest Value added (constant 2005 US$) of 1960?
Offer a terse response. 2.45e+1. What is the difference between the highest and the second highest Value added (constant 2005 US$) of 1961?
Provide a short and direct response. 2.59e+1. What is the difference between the highest and the second highest Value added (constant 2005 US$) in 1962?
Offer a very short reply. 2.64e+1. What is the difference between the highest and the second highest Value added (constant 2005 US$) in 1963?
Make the answer very short. 3.21e+1. What is the difference between the highest and the lowest Value added (constant 2005 US$) in 1960?
Your answer should be very brief. 4.06e+1. What is the difference between the highest and the lowest Value added (constant 2005 US$) of 1961?
Provide a short and direct response. 4.12e+1. What is the difference between the highest and the lowest Value added (constant 2005 US$) in 1962?
Your answer should be compact. 4.30e+1. What is the difference between the highest and the lowest Value added (constant 2005 US$) in 1963?
Offer a terse response. 4.79e+1. 